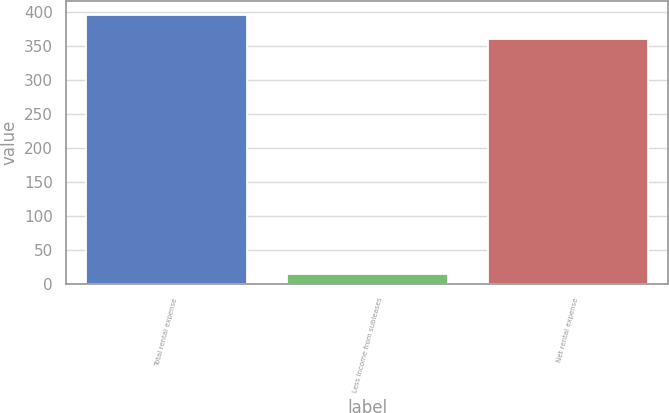<chart> <loc_0><loc_0><loc_500><loc_500><bar_chart><fcel>Total rental expense<fcel>Less Income from subleases<fcel>Net rental expense<nl><fcel>396<fcel>15<fcel>360<nl></chart> 